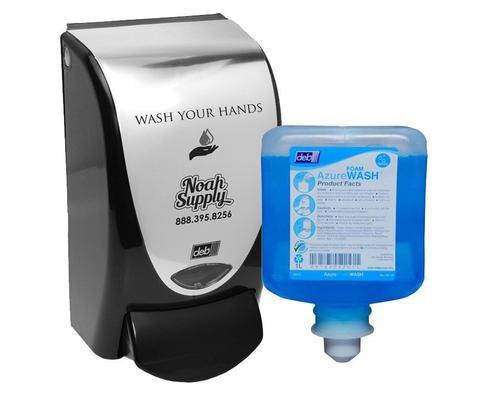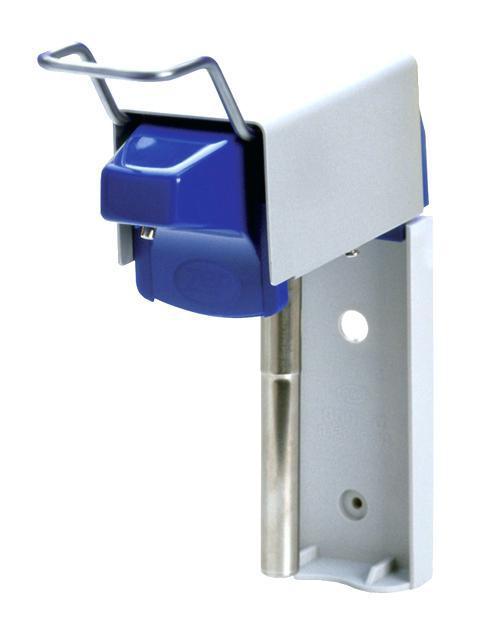The first image is the image on the left, the second image is the image on the right. Examine the images to the left and right. Is the description "One soap container is brown." accurate? Answer yes or no. No. 